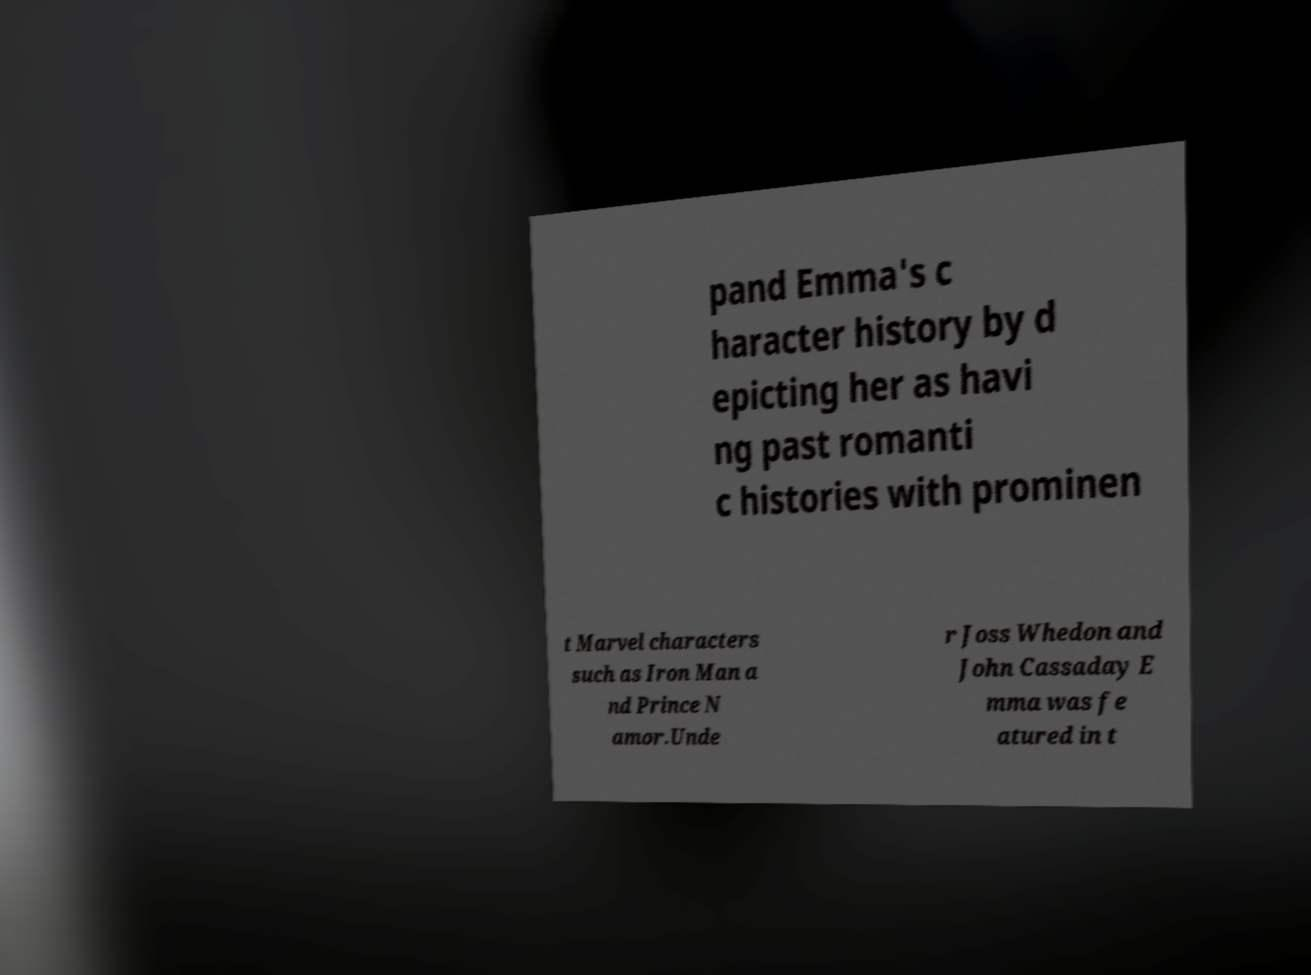Could you extract and type out the text from this image? pand Emma's c haracter history by d epicting her as havi ng past romanti c histories with prominen t Marvel characters such as Iron Man a nd Prince N amor.Unde r Joss Whedon and John Cassaday E mma was fe atured in t 